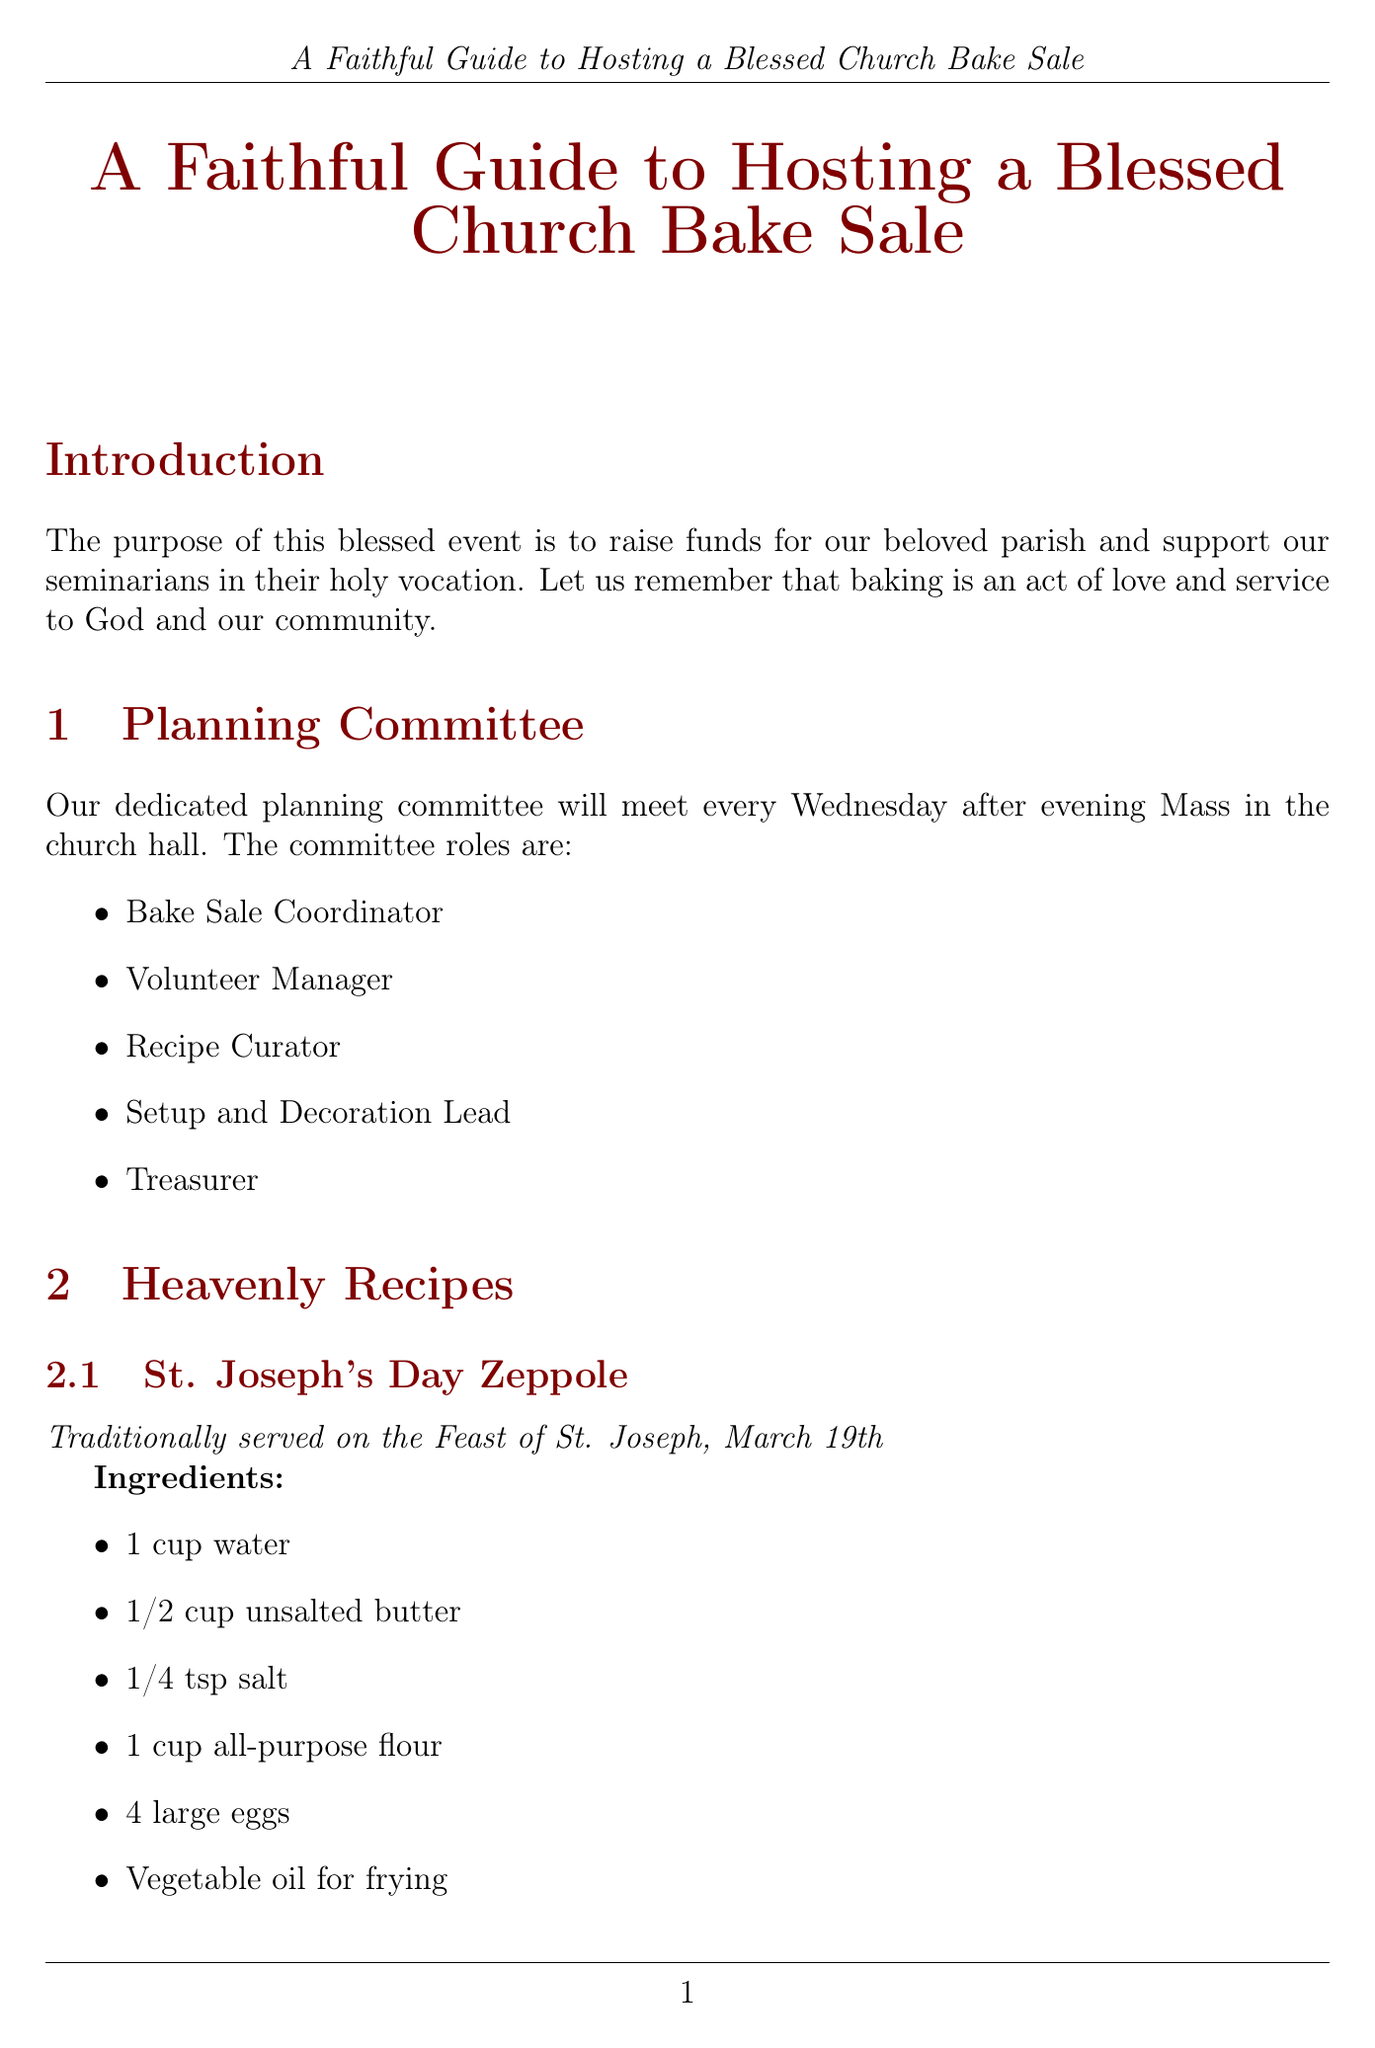What is the purpose of the bake sale? The purpose of the bake sale is to raise funds for the parish and support seminarians in their holy vocation.
Answer: To raise funds for our beloved parish and support our seminarians in their holy vocation When is the planning committee's meeting scheduled? The planning committee meets every Wednesday after evening Mass in the church hall.
Answer: Every Wednesday after evening Mass What are the ingredients for St. Joseph's Day Zeppole? The recipe lists specific ingredients needed for St. Joseph's Day Zeppole.
Answer: 1 cup water, 1/2 cup unsalted butter, 1/4 tsp salt, 1 cup all-purpose flour, 4 large eggs, vegetable oil for frying, powdered sugar for dusting How long should the cookies be baked? The baking time for the cookies is specified in the instructions.
Answer: 15 minutes What roles can volunteers sign up for? The document outlines specific roles for volunteers.
Answer: Bakers, Cashiers, Setup and Cleanup Crew, Greeters, Prayer Warriors What decoration items are included for the bake sale? The section describes various decorations used for the bake sale.
Answer: White tablecloths, Fresh flowers, Holy cards for customers, Pictures of parish seminarians, Banner with the bake sale's purpose What is the suggested price range for cookies? The pricing strategy provides specific price ranges for different baked goods.
Answer: $0.50 - $1 each What time does the bake sale open? The schedule outlines the timing of the event, including when it opens.
Answer: 10:00 AM 